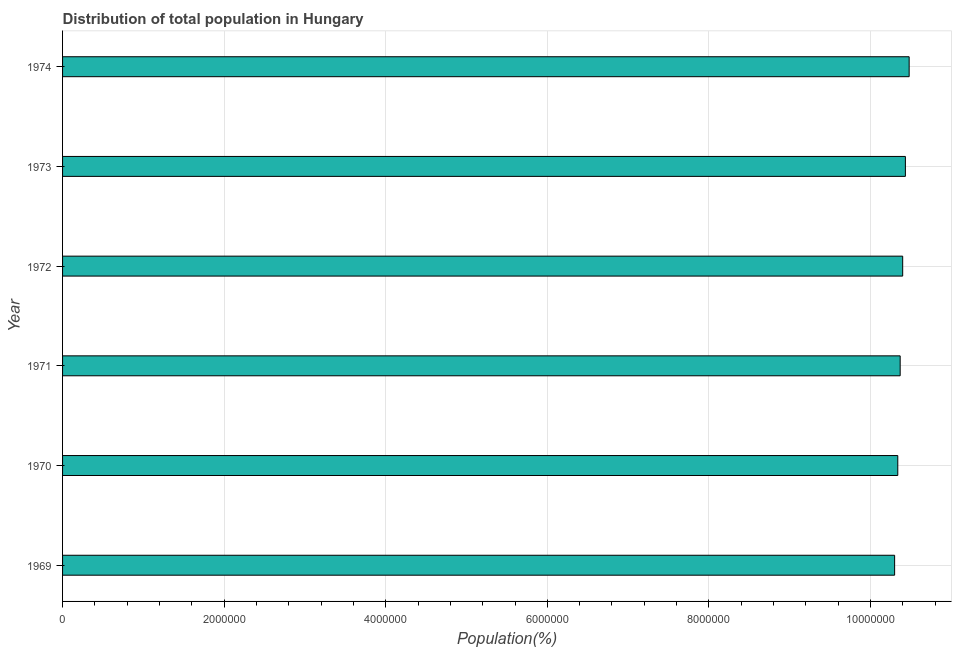Does the graph contain grids?
Give a very brief answer. Yes. What is the title of the graph?
Make the answer very short. Distribution of total population in Hungary . What is the label or title of the X-axis?
Offer a terse response. Population(%). What is the population in 1971?
Your response must be concise. 1.04e+07. Across all years, what is the maximum population?
Offer a very short reply. 1.05e+07. Across all years, what is the minimum population?
Give a very brief answer. 1.03e+07. In which year was the population maximum?
Offer a very short reply. 1974. In which year was the population minimum?
Offer a terse response. 1969. What is the sum of the population?
Offer a very short reply. 6.23e+07. What is the difference between the population in 1969 and 1970?
Make the answer very short. -3.92e+04. What is the average population per year?
Offer a terse response. 1.04e+07. What is the median population?
Your answer should be compact. 1.04e+07. In how many years, is the population greater than 9600000 %?
Keep it short and to the point. 6. Is the difference between the population in 1969 and 1974 greater than the difference between any two years?
Ensure brevity in your answer.  Yes. What is the difference between the highest and the second highest population?
Give a very brief answer. 4.67e+04. Is the sum of the population in 1973 and 1974 greater than the maximum population across all years?
Offer a terse response. Yes. What is the difference between the highest and the lowest population?
Your answer should be compact. 1.80e+05. In how many years, is the population greater than the average population taken over all years?
Your answer should be compact. 3. Are all the bars in the graph horizontal?
Ensure brevity in your answer.  Yes. How many years are there in the graph?
Your answer should be compact. 6. Are the values on the major ticks of X-axis written in scientific E-notation?
Keep it short and to the point. No. What is the Population(%) of 1969?
Offer a terse response. 1.03e+07. What is the Population(%) of 1970?
Provide a succinct answer. 1.03e+07. What is the Population(%) of 1971?
Your answer should be compact. 1.04e+07. What is the Population(%) of 1972?
Provide a short and direct response. 1.04e+07. What is the Population(%) in 1973?
Ensure brevity in your answer.  1.04e+07. What is the Population(%) in 1974?
Provide a short and direct response. 1.05e+07. What is the difference between the Population(%) in 1969 and 1970?
Offer a terse response. -3.92e+04. What is the difference between the Population(%) in 1969 and 1971?
Offer a very short reply. -6.88e+04. What is the difference between the Population(%) in 1969 and 1972?
Ensure brevity in your answer.  -9.98e+04. What is the difference between the Population(%) in 1969 and 1973?
Give a very brief answer. -1.33e+05. What is the difference between the Population(%) in 1969 and 1974?
Offer a very short reply. -1.80e+05. What is the difference between the Population(%) in 1970 and 1971?
Your answer should be very brief. -2.96e+04. What is the difference between the Population(%) in 1970 and 1972?
Your answer should be very brief. -6.06e+04. What is the difference between the Population(%) in 1970 and 1973?
Give a very brief answer. -9.41e+04. What is the difference between the Population(%) in 1970 and 1974?
Give a very brief answer. -1.41e+05. What is the difference between the Population(%) in 1971 and 1972?
Offer a very short reply. -3.10e+04. What is the difference between the Population(%) in 1971 and 1973?
Give a very brief answer. -6.45e+04. What is the difference between the Population(%) in 1971 and 1974?
Provide a short and direct response. -1.11e+05. What is the difference between the Population(%) in 1972 and 1973?
Keep it short and to the point. -3.36e+04. What is the difference between the Population(%) in 1972 and 1974?
Ensure brevity in your answer.  -8.02e+04. What is the difference between the Population(%) in 1973 and 1974?
Offer a terse response. -4.67e+04. What is the ratio of the Population(%) in 1969 to that in 1970?
Your response must be concise. 1. What is the ratio of the Population(%) in 1969 to that in 1971?
Your answer should be compact. 0.99. What is the ratio of the Population(%) in 1969 to that in 1974?
Your answer should be very brief. 0.98. What is the ratio of the Population(%) in 1970 to that in 1973?
Provide a short and direct response. 0.99. What is the ratio of the Population(%) in 1970 to that in 1974?
Ensure brevity in your answer.  0.99. What is the ratio of the Population(%) in 1971 to that in 1974?
Offer a very short reply. 0.99. What is the ratio of the Population(%) in 1972 to that in 1973?
Offer a very short reply. 1. What is the ratio of the Population(%) in 1973 to that in 1974?
Offer a very short reply. 1. 